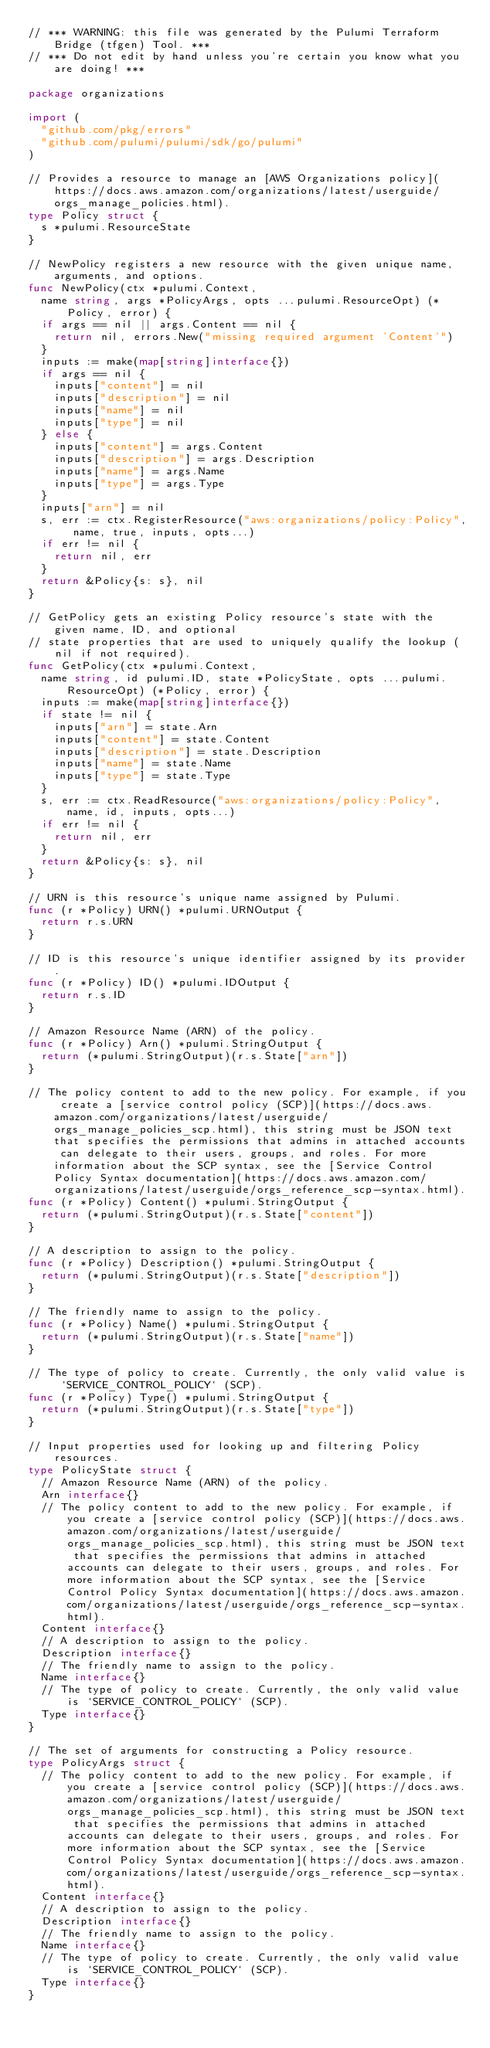Convert code to text. <code><loc_0><loc_0><loc_500><loc_500><_Go_>// *** WARNING: this file was generated by the Pulumi Terraform Bridge (tfgen) Tool. ***
// *** Do not edit by hand unless you're certain you know what you are doing! ***

package organizations

import (
	"github.com/pkg/errors"
	"github.com/pulumi/pulumi/sdk/go/pulumi"
)

// Provides a resource to manage an [AWS Organizations policy](https://docs.aws.amazon.com/organizations/latest/userguide/orgs_manage_policies.html).
type Policy struct {
	s *pulumi.ResourceState
}

// NewPolicy registers a new resource with the given unique name, arguments, and options.
func NewPolicy(ctx *pulumi.Context,
	name string, args *PolicyArgs, opts ...pulumi.ResourceOpt) (*Policy, error) {
	if args == nil || args.Content == nil {
		return nil, errors.New("missing required argument 'Content'")
	}
	inputs := make(map[string]interface{})
	if args == nil {
		inputs["content"] = nil
		inputs["description"] = nil
		inputs["name"] = nil
		inputs["type"] = nil
	} else {
		inputs["content"] = args.Content
		inputs["description"] = args.Description
		inputs["name"] = args.Name
		inputs["type"] = args.Type
	}
	inputs["arn"] = nil
	s, err := ctx.RegisterResource("aws:organizations/policy:Policy", name, true, inputs, opts...)
	if err != nil {
		return nil, err
	}
	return &Policy{s: s}, nil
}

// GetPolicy gets an existing Policy resource's state with the given name, ID, and optional
// state properties that are used to uniquely qualify the lookup (nil if not required).
func GetPolicy(ctx *pulumi.Context,
	name string, id pulumi.ID, state *PolicyState, opts ...pulumi.ResourceOpt) (*Policy, error) {
	inputs := make(map[string]interface{})
	if state != nil {
		inputs["arn"] = state.Arn
		inputs["content"] = state.Content
		inputs["description"] = state.Description
		inputs["name"] = state.Name
		inputs["type"] = state.Type
	}
	s, err := ctx.ReadResource("aws:organizations/policy:Policy", name, id, inputs, opts...)
	if err != nil {
		return nil, err
	}
	return &Policy{s: s}, nil
}

// URN is this resource's unique name assigned by Pulumi.
func (r *Policy) URN() *pulumi.URNOutput {
	return r.s.URN
}

// ID is this resource's unique identifier assigned by its provider.
func (r *Policy) ID() *pulumi.IDOutput {
	return r.s.ID
}

// Amazon Resource Name (ARN) of the policy.
func (r *Policy) Arn() *pulumi.StringOutput {
	return (*pulumi.StringOutput)(r.s.State["arn"])
}

// The policy content to add to the new policy. For example, if you create a [service control policy (SCP)](https://docs.aws.amazon.com/organizations/latest/userguide/orgs_manage_policies_scp.html), this string must be JSON text that specifies the permissions that admins in attached accounts can delegate to their users, groups, and roles. For more information about the SCP syntax, see the [Service Control Policy Syntax documentation](https://docs.aws.amazon.com/organizations/latest/userguide/orgs_reference_scp-syntax.html).
func (r *Policy) Content() *pulumi.StringOutput {
	return (*pulumi.StringOutput)(r.s.State["content"])
}

// A description to assign to the policy.
func (r *Policy) Description() *pulumi.StringOutput {
	return (*pulumi.StringOutput)(r.s.State["description"])
}

// The friendly name to assign to the policy.
func (r *Policy) Name() *pulumi.StringOutput {
	return (*pulumi.StringOutput)(r.s.State["name"])
}

// The type of policy to create. Currently, the only valid value is `SERVICE_CONTROL_POLICY` (SCP).
func (r *Policy) Type() *pulumi.StringOutput {
	return (*pulumi.StringOutput)(r.s.State["type"])
}

// Input properties used for looking up and filtering Policy resources.
type PolicyState struct {
	// Amazon Resource Name (ARN) of the policy.
	Arn interface{}
	// The policy content to add to the new policy. For example, if you create a [service control policy (SCP)](https://docs.aws.amazon.com/organizations/latest/userguide/orgs_manage_policies_scp.html), this string must be JSON text that specifies the permissions that admins in attached accounts can delegate to their users, groups, and roles. For more information about the SCP syntax, see the [Service Control Policy Syntax documentation](https://docs.aws.amazon.com/organizations/latest/userguide/orgs_reference_scp-syntax.html).
	Content interface{}
	// A description to assign to the policy.
	Description interface{}
	// The friendly name to assign to the policy.
	Name interface{}
	// The type of policy to create. Currently, the only valid value is `SERVICE_CONTROL_POLICY` (SCP).
	Type interface{}
}

// The set of arguments for constructing a Policy resource.
type PolicyArgs struct {
	// The policy content to add to the new policy. For example, if you create a [service control policy (SCP)](https://docs.aws.amazon.com/organizations/latest/userguide/orgs_manage_policies_scp.html), this string must be JSON text that specifies the permissions that admins in attached accounts can delegate to their users, groups, and roles. For more information about the SCP syntax, see the [Service Control Policy Syntax documentation](https://docs.aws.amazon.com/organizations/latest/userguide/orgs_reference_scp-syntax.html).
	Content interface{}
	// A description to assign to the policy.
	Description interface{}
	// The friendly name to assign to the policy.
	Name interface{}
	// The type of policy to create. Currently, the only valid value is `SERVICE_CONTROL_POLICY` (SCP).
	Type interface{}
}
</code> 